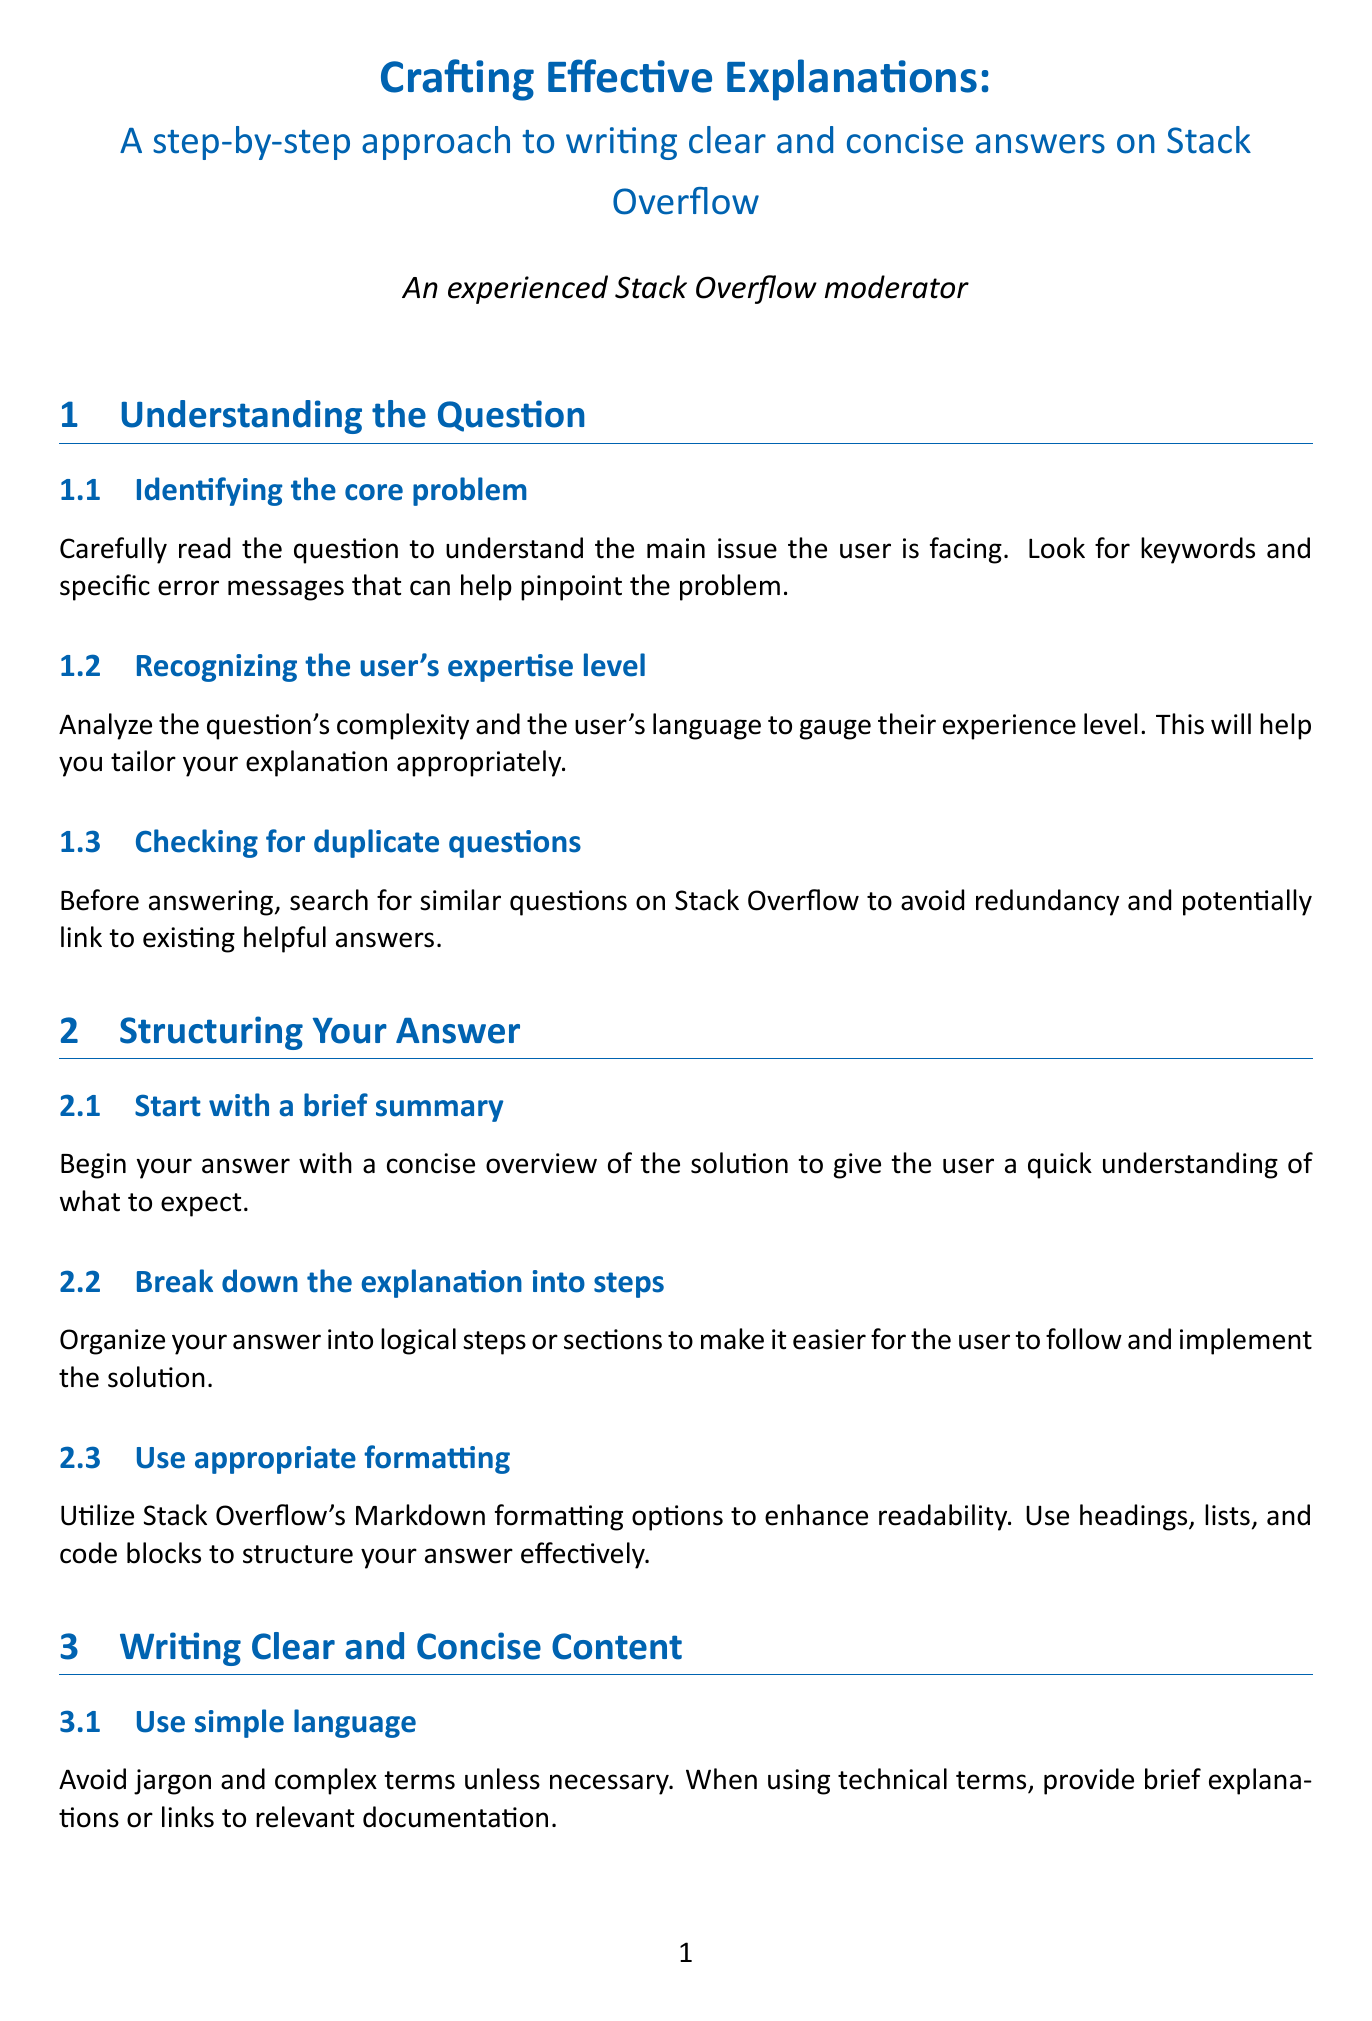What is the title of the document? The title is presented prominently at the top of the document, encapsulating the main theme regarding effective explanations on Stack Overflow.
Answer: Crafting Effective Explanations: A step-by-step approach to writing clear and concise answers on Stack Overflow How many main sections are in the document? The document is organized into several main sections which guide the process of crafting an effective explanation, totaling five sections.
Answer: 5 What should you provide when using technical terms? The section on writing clear content emphasizes the need to clarify technical terms to ensure understanding by a wider audience.
Answer: Brief explanations or links to relevant documentation What is one way to enhance your answer? Enhancing an answer involves various strategies, one of which is to include external resources that relate to the original topic for better user context.
Answer: Include relevant links and resources What kind of tone should you maintain when answering questions? The document stresses the importance of a certain attitude when responding, particularly in relation to the user's experience and background.
Answer: Patient and encouraging How should you begin your answer? Starting the answer with an overview is recommended to orient the user to what they can expect from your solution.
Answer: A concise overview of the solution What does the document suggest you do before submitting your answer? It highlights the necessity of reviewing your content to ensure quality and correctness, which includes checking for basic errors.
Answer: Proofread for clarity and correctness What should you do if your answer is subject to feedback? The document encourages embracing community interaction to allow for improvement and greater accuracy in your explanations after publication.
Answer: Be open to feedback and improvements 